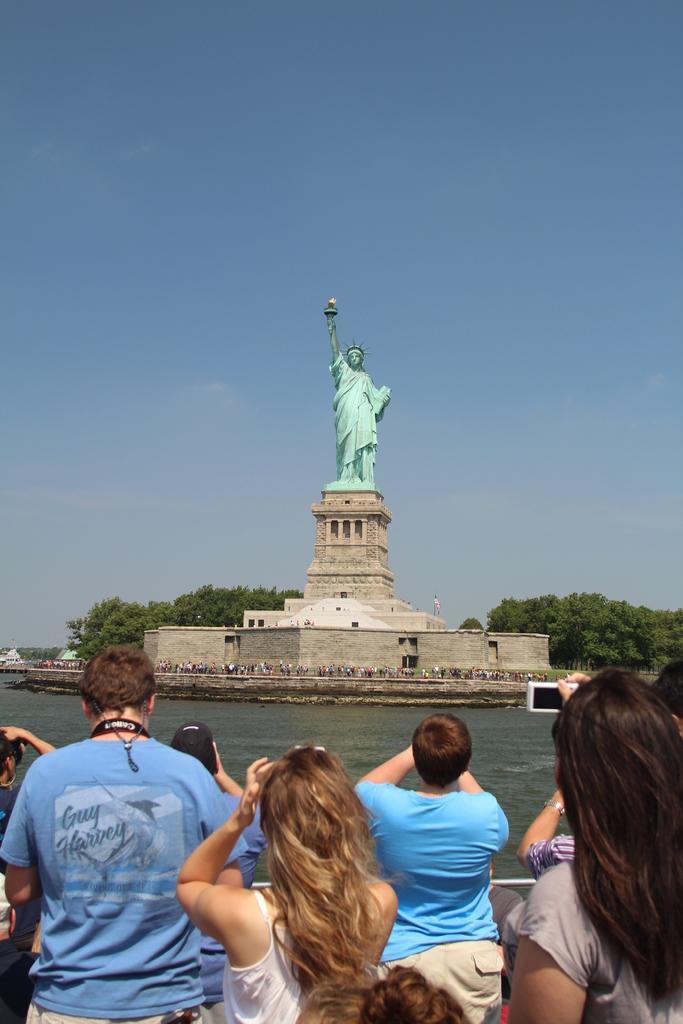Can you describe this image briefly? In this picture I can see the statue of liberty. At the bottom of the picture I can see many persons who are holding the mobile phones and cameras and taking the picture of that statue. In the background I can see the lake, trees and other objects. At the top I can see the sky and clouds. 